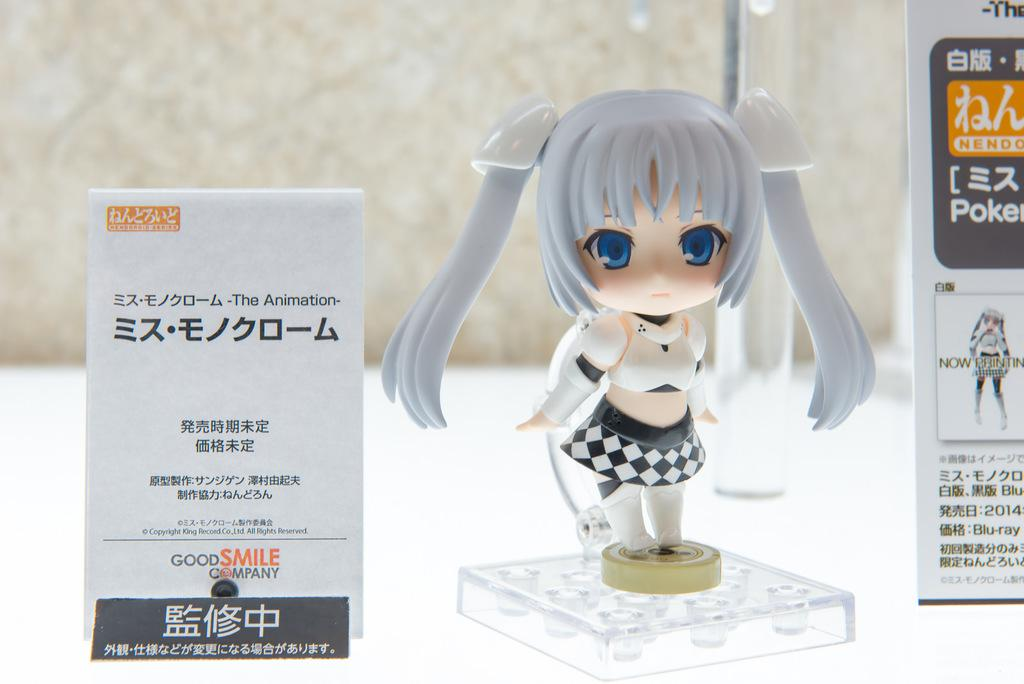What is the main subject of the image? There is a doll in the shape of a girl in the image. What can be seen on either side of the image? There are boards on either side of the image. How many legs does the sugar have in the image? There is no sugar present in the image, and therefore no legs can be attributed to it. 